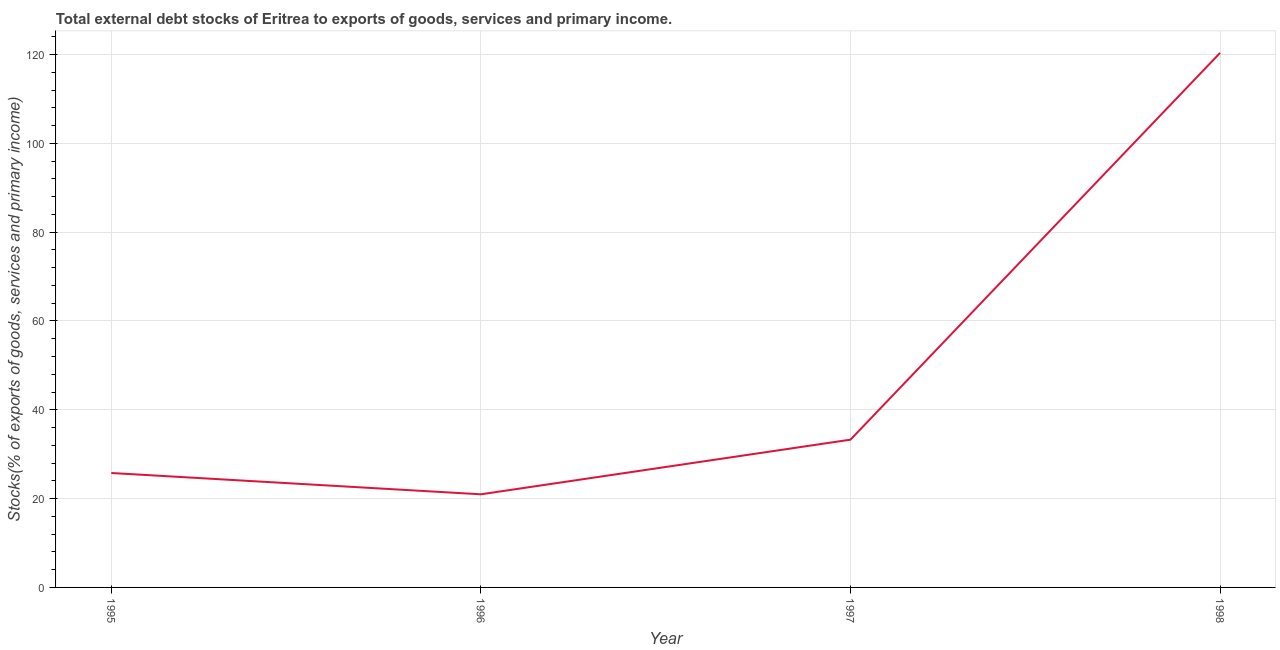What is the external debt stocks in 1997?
Offer a very short reply. 33.27. Across all years, what is the maximum external debt stocks?
Your answer should be very brief. 120.36. Across all years, what is the minimum external debt stocks?
Offer a terse response. 20.97. What is the sum of the external debt stocks?
Provide a succinct answer. 200.37. What is the difference between the external debt stocks in 1996 and 1998?
Provide a succinct answer. -99.39. What is the average external debt stocks per year?
Your answer should be very brief. 50.09. What is the median external debt stocks?
Give a very brief answer. 29.52. In how many years, is the external debt stocks greater than 116 %?
Your answer should be very brief. 1. What is the ratio of the external debt stocks in 1995 to that in 1998?
Give a very brief answer. 0.21. What is the difference between the highest and the second highest external debt stocks?
Provide a short and direct response. 87.09. Is the sum of the external debt stocks in 1995 and 1997 greater than the maximum external debt stocks across all years?
Your answer should be compact. No. What is the difference between the highest and the lowest external debt stocks?
Your answer should be compact. 99.39. In how many years, is the external debt stocks greater than the average external debt stocks taken over all years?
Keep it short and to the point. 1. How many lines are there?
Keep it short and to the point. 1. How many years are there in the graph?
Offer a very short reply. 4. Does the graph contain grids?
Ensure brevity in your answer.  Yes. What is the title of the graph?
Your answer should be very brief. Total external debt stocks of Eritrea to exports of goods, services and primary income. What is the label or title of the Y-axis?
Give a very brief answer. Stocks(% of exports of goods, services and primary income). What is the Stocks(% of exports of goods, services and primary income) in 1995?
Keep it short and to the point. 25.77. What is the Stocks(% of exports of goods, services and primary income) of 1996?
Ensure brevity in your answer.  20.97. What is the Stocks(% of exports of goods, services and primary income) in 1997?
Provide a succinct answer. 33.27. What is the Stocks(% of exports of goods, services and primary income) in 1998?
Your answer should be compact. 120.36. What is the difference between the Stocks(% of exports of goods, services and primary income) in 1995 and 1996?
Ensure brevity in your answer.  4.8. What is the difference between the Stocks(% of exports of goods, services and primary income) in 1995 and 1997?
Offer a terse response. -7.5. What is the difference between the Stocks(% of exports of goods, services and primary income) in 1995 and 1998?
Your response must be concise. -94.6. What is the difference between the Stocks(% of exports of goods, services and primary income) in 1996 and 1997?
Keep it short and to the point. -12.3. What is the difference between the Stocks(% of exports of goods, services and primary income) in 1996 and 1998?
Your answer should be very brief. -99.39. What is the difference between the Stocks(% of exports of goods, services and primary income) in 1997 and 1998?
Ensure brevity in your answer.  -87.09. What is the ratio of the Stocks(% of exports of goods, services and primary income) in 1995 to that in 1996?
Your response must be concise. 1.23. What is the ratio of the Stocks(% of exports of goods, services and primary income) in 1995 to that in 1997?
Offer a very short reply. 0.77. What is the ratio of the Stocks(% of exports of goods, services and primary income) in 1995 to that in 1998?
Your answer should be compact. 0.21. What is the ratio of the Stocks(% of exports of goods, services and primary income) in 1996 to that in 1997?
Offer a terse response. 0.63. What is the ratio of the Stocks(% of exports of goods, services and primary income) in 1996 to that in 1998?
Offer a very short reply. 0.17. What is the ratio of the Stocks(% of exports of goods, services and primary income) in 1997 to that in 1998?
Keep it short and to the point. 0.28. 